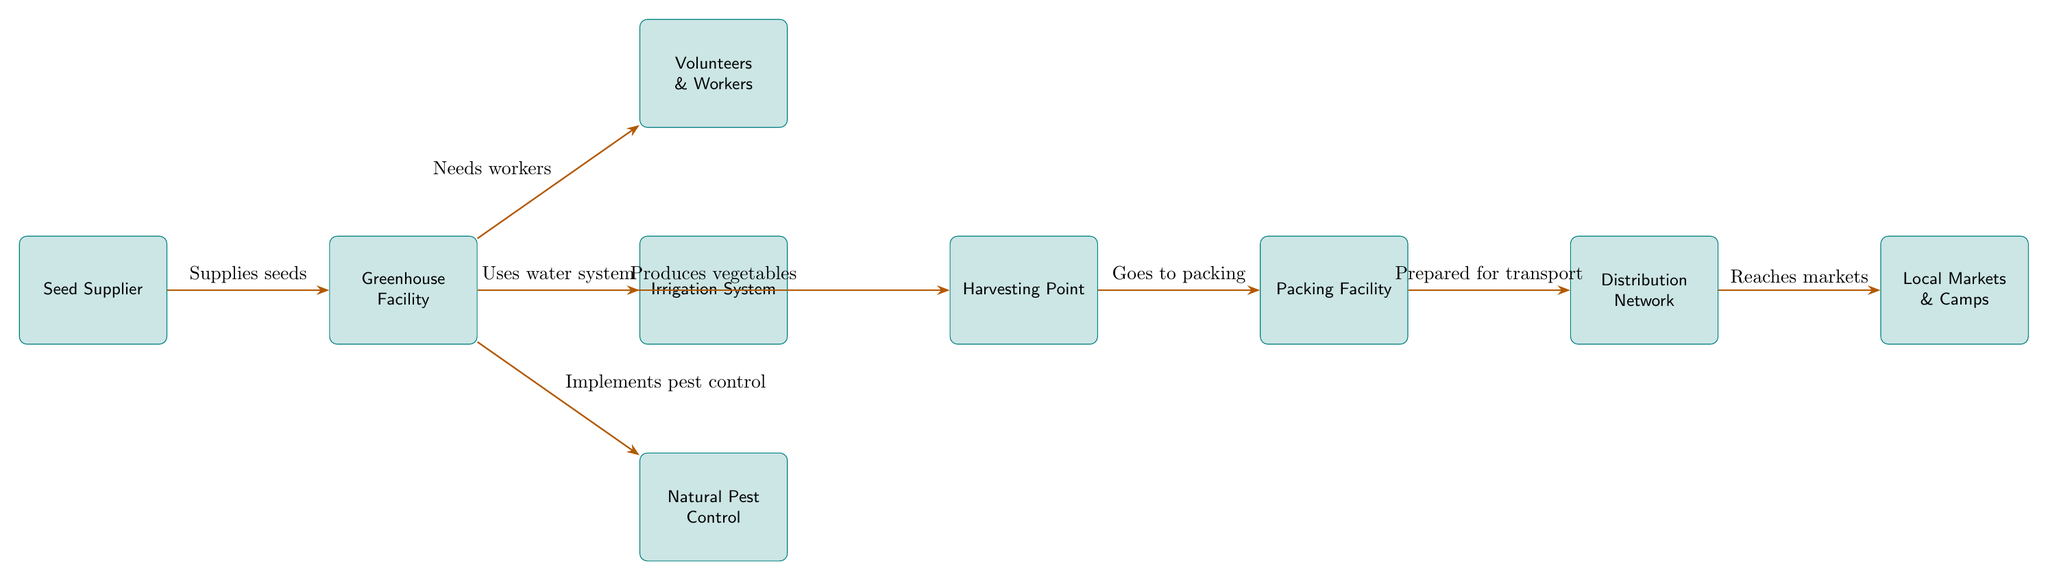What is the first step in the food chain? The first step is represented by the node labeled "Seed Supplier," which indicates the starting point of the food chain where seeds are sourced.
Answer: Seed Supplier How many nodes are present in the diagram? By counting each distinct box in the diagram, we see there are a total of 8 nodes connected through various actions.
Answer: 8 Which node receives water from the irrigation system? The diagram shows an arrow labeled "Uses water system" directed from the "Greenhouse Facility" to the "Irrigation System," indicating that the greenhouse receives water from this node.
Answer: Greenhouse Facility What follows after the harvesting point? The diagram illustrates an arrow from the "Harvesting Point" to the "Packing Facility," indicating that the process continues from harvesting to packing.
Answer: Packing Facility Which node is related to natural pest control? The node "Natural Pest Control" is directly connected to the "Greenhouse Facility" and is described in the diagram with the action "Implements pest control."
Answer: Natural Pest Control How does the distribution network affect local markets? The diagram indicates that the "Distribution Network" leads to the "Local Markets & Camps," showing that the distribution facilitates transportation and reaches these markets.
Answer: Reaches markets What role do volunteers and workers play in this diagram? The diagram notes that "Volunteers & Workers" are needed by the "Greenhouse Facility," indicating their role in supporting greenhouse operations.
Answer: Needs workers Which step produces vegetables in the food chain? The diagram clearly shows that the "Greenhouse Facility" is responsible for producing vegetables, as marked by the flow labeled "Produces vegetables."
Answer: Produces vegetables 